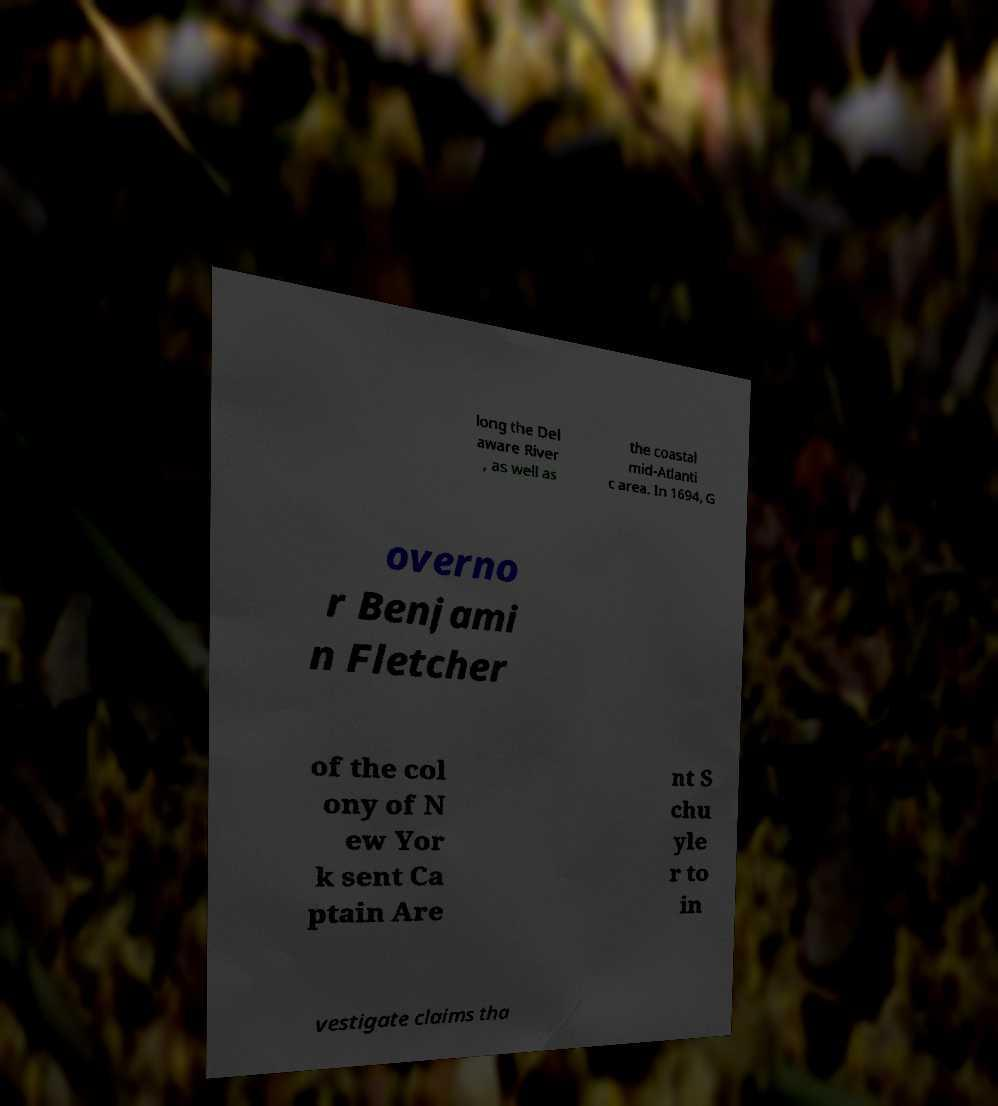For documentation purposes, I need the text within this image transcribed. Could you provide that? long the Del aware River , as well as the coastal mid-Atlanti c area. In 1694, G overno r Benjami n Fletcher of the col ony of N ew Yor k sent Ca ptain Are nt S chu yle r to in vestigate claims tha 